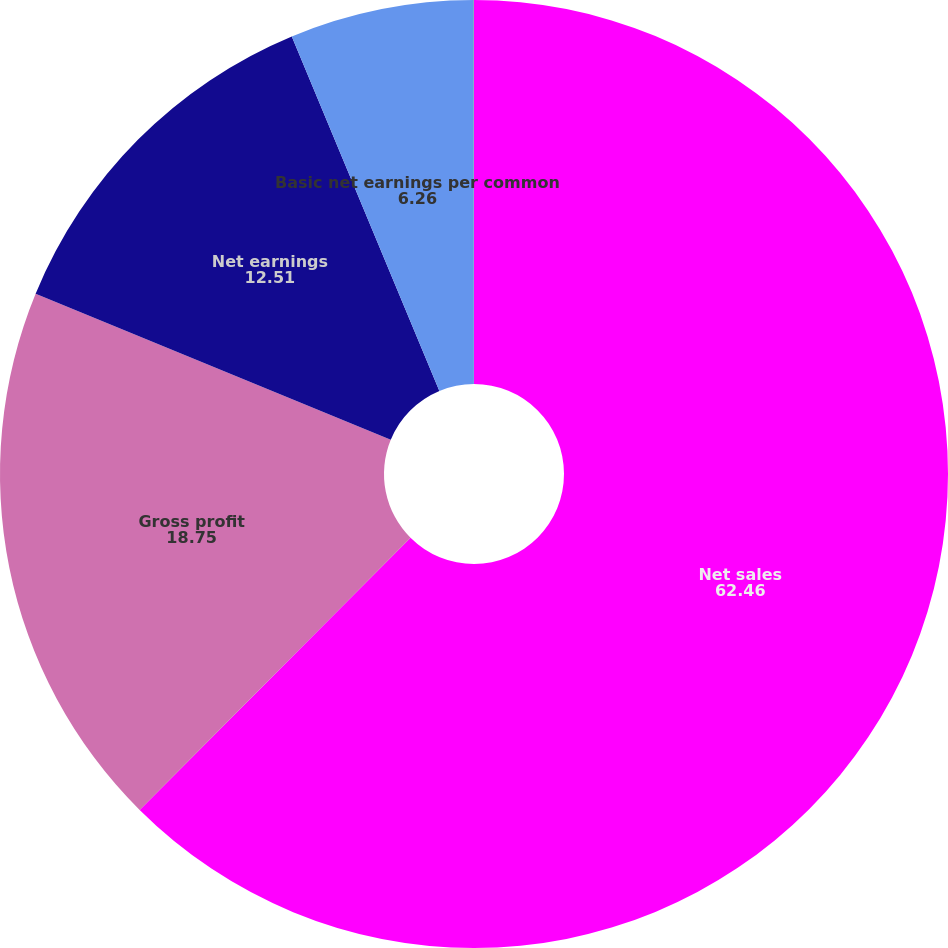Convert chart to OTSL. <chart><loc_0><loc_0><loc_500><loc_500><pie_chart><fcel>Net sales<fcel>Gross profit<fcel>Net earnings<fcel>Basic net earnings per common<fcel>Diluted net earnings per<nl><fcel>62.46%<fcel>18.75%<fcel>12.51%<fcel>6.26%<fcel>0.02%<nl></chart> 